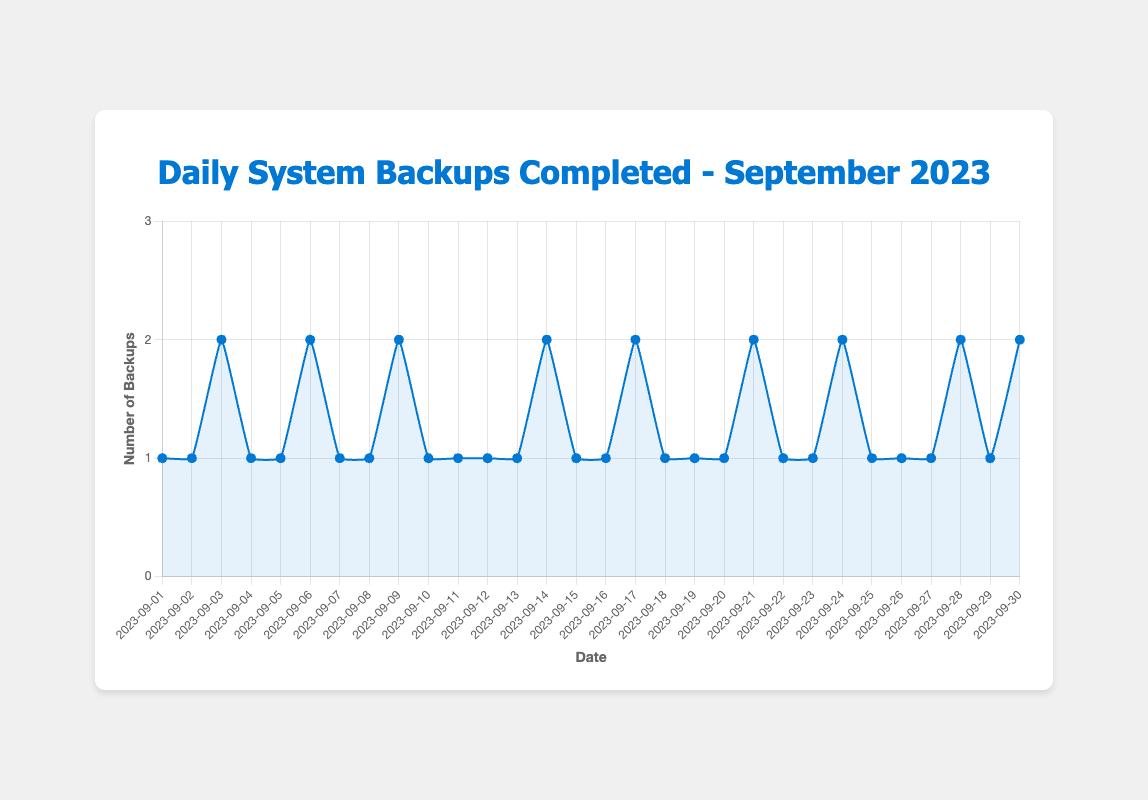What date had the highest number of backups completed? By observing the peaks in the line chart, we can see that the highest number of backups completed on any given day is 2. Several dates show 2 backups completed, including September 3, 6, 9, 14, 17, 21, 24, 28, and 30.
Answer: September 3, 6, 9, 14, 17, 21, 24, 28, 30 What is the average number of backups completed per day in September 2023? To find the average, sum up all the daily backups completed and divide by the number of days in September. The total backups are (1+1+2+1+1+2+1+1+2+1+1+1+1+2+1+1+2+1+1+1+2+1+1+2+1+1+1+2+1+2) = 43. There are 30 days in September, so the average is 43 / 30 ≈ 1.43.
Answer: 1.43 Which date shows a sudden increase in the number of backups completed compared to the previous day? We need to look for dates where the number of backups completed increases from 1 to 2. The chart shows these increases on September 3 (from 1 to 2), September 6 (from 1 to 2), September 9 (from 1 to 2), and so on.
Answer: September 3, 6, 9, 14, 17, 21, 24, 28, 30 How many times did exactly two backups get completed in September 2023? By counting the number of times the value hits 2 in the chart, we see it happens on September 3, 6, 9, 14, 17, 21, 24, 28, and 30. This gives us a total of 9 times.
Answer: 9 Compare the number of backups completed in the first half of the month (September 1-15) with the second half (September 16-30). Which period had more backups completed? Sum the backups for each period: 
First half: 1+1+2+1+1+2+1+1+2+1+1+1+1+2+1 = 18 
Second half: 1+2+1+1+2+1+1+2+1+1+2+1+2 = 25 
The second half of the month had more backups completed.
Answer: Second half What is the total number of backups completed on weekends in September 2023? Weekends in September are on 2-3, 9-10, 16-17, 23-24, and 30. Adding the backups for these dates: 1+2+2+1+1+2+1+2+2 = 14.
Answer: 14 